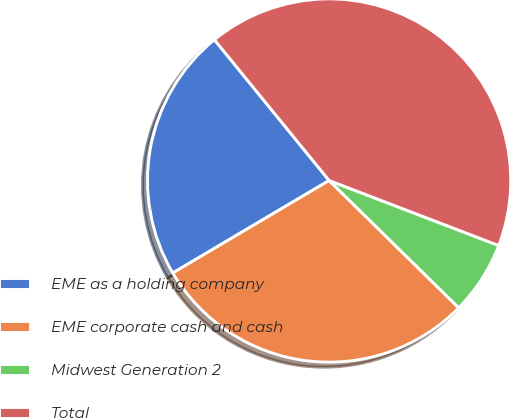Convert chart to OTSL. <chart><loc_0><loc_0><loc_500><loc_500><pie_chart><fcel>EME as a holding company<fcel>EME corporate cash and cash<fcel>Midwest Generation 2<fcel>Total<nl><fcel>22.62%<fcel>29.14%<fcel>6.53%<fcel>41.71%<nl></chart> 